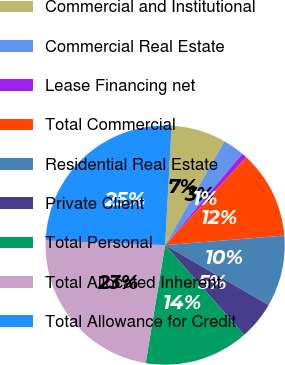Convert chart to OTSL. <chart><loc_0><loc_0><loc_500><loc_500><pie_chart><fcel>Commercial and Institutional<fcel>Commercial Real Estate<fcel>Lease Financing net<fcel>Total Commercial<fcel>Residential Real Estate<fcel>Private Client<fcel>Total Personal<fcel>Total Allocated Inherent<fcel>Total Allowance for Credit<nl><fcel>7.39%<fcel>2.92%<fcel>0.69%<fcel>11.86%<fcel>9.62%<fcel>5.16%<fcel>14.09%<fcel>23.02%<fcel>25.25%<nl></chart> 